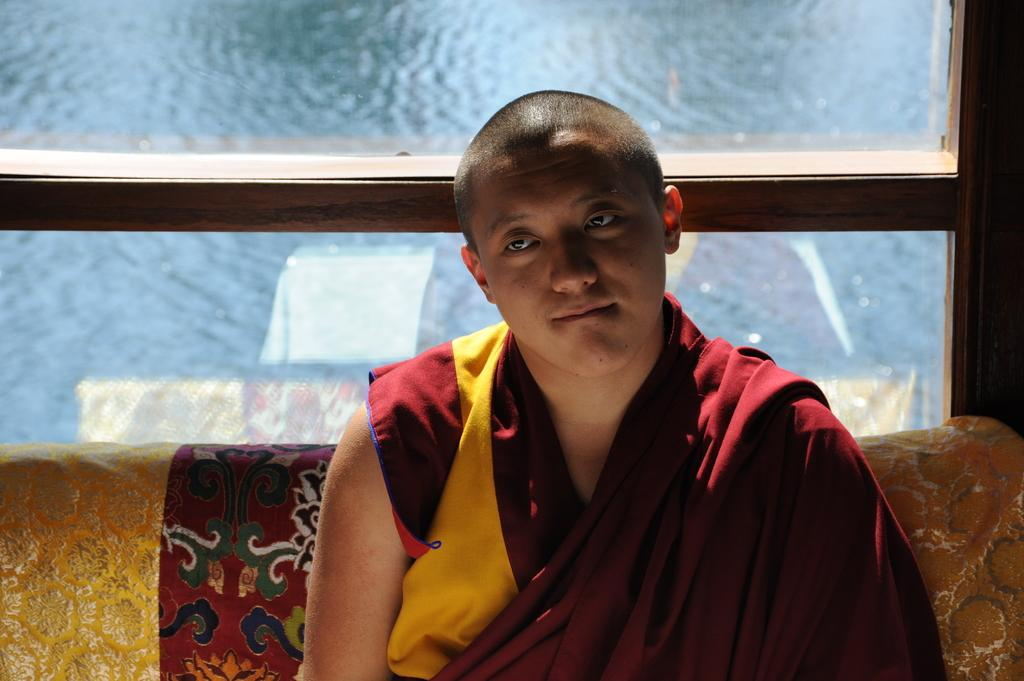Where was the image taken? The image is taken indoors. What is the man in the image doing? The man is sitting on a couch in the image. What can be seen in the background of the image? There is a window in the background of the image. What is visible through the window? A river with water is visible through the window. How many cats are touching the man's feet in the image? There are no cats present in the image, and therefore, none are touching the man's feet. 